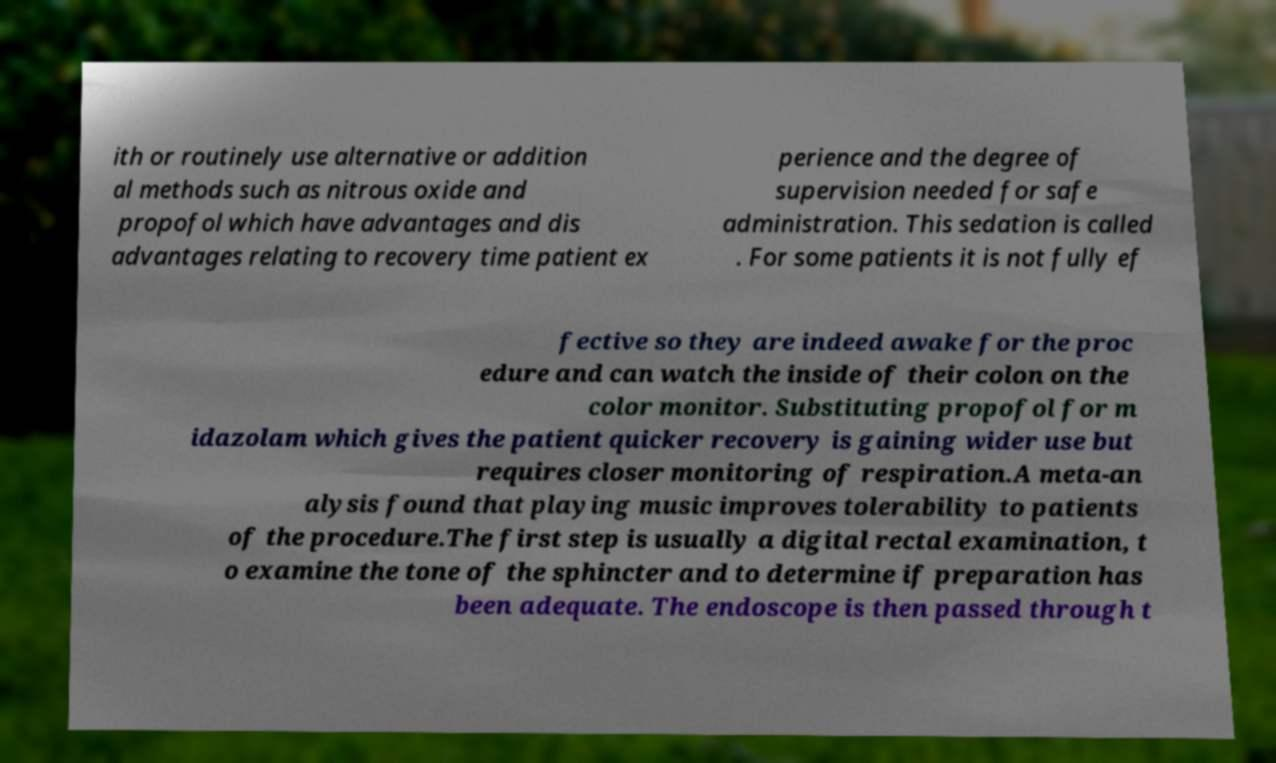Please read and relay the text visible in this image. What does it say? ith or routinely use alternative or addition al methods such as nitrous oxide and propofol which have advantages and dis advantages relating to recovery time patient ex perience and the degree of supervision needed for safe administration. This sedation is called . For some patients it is not fully ef fective so they are indeed awake for the proc edure and can watch the inside of their colon on the color monitor. Substituting propofol for m idazolam which gives the patient quicker recovery is gaining wider use but requires closer monitoring of respiration.A meta-an alysis found that playing music improves tolerability to patients of the procedure.The first step is usually a digital rectal examination, t o examine the tone of the sphincter and to determine if preparation has been adequate. The endoscope is then passed through t 